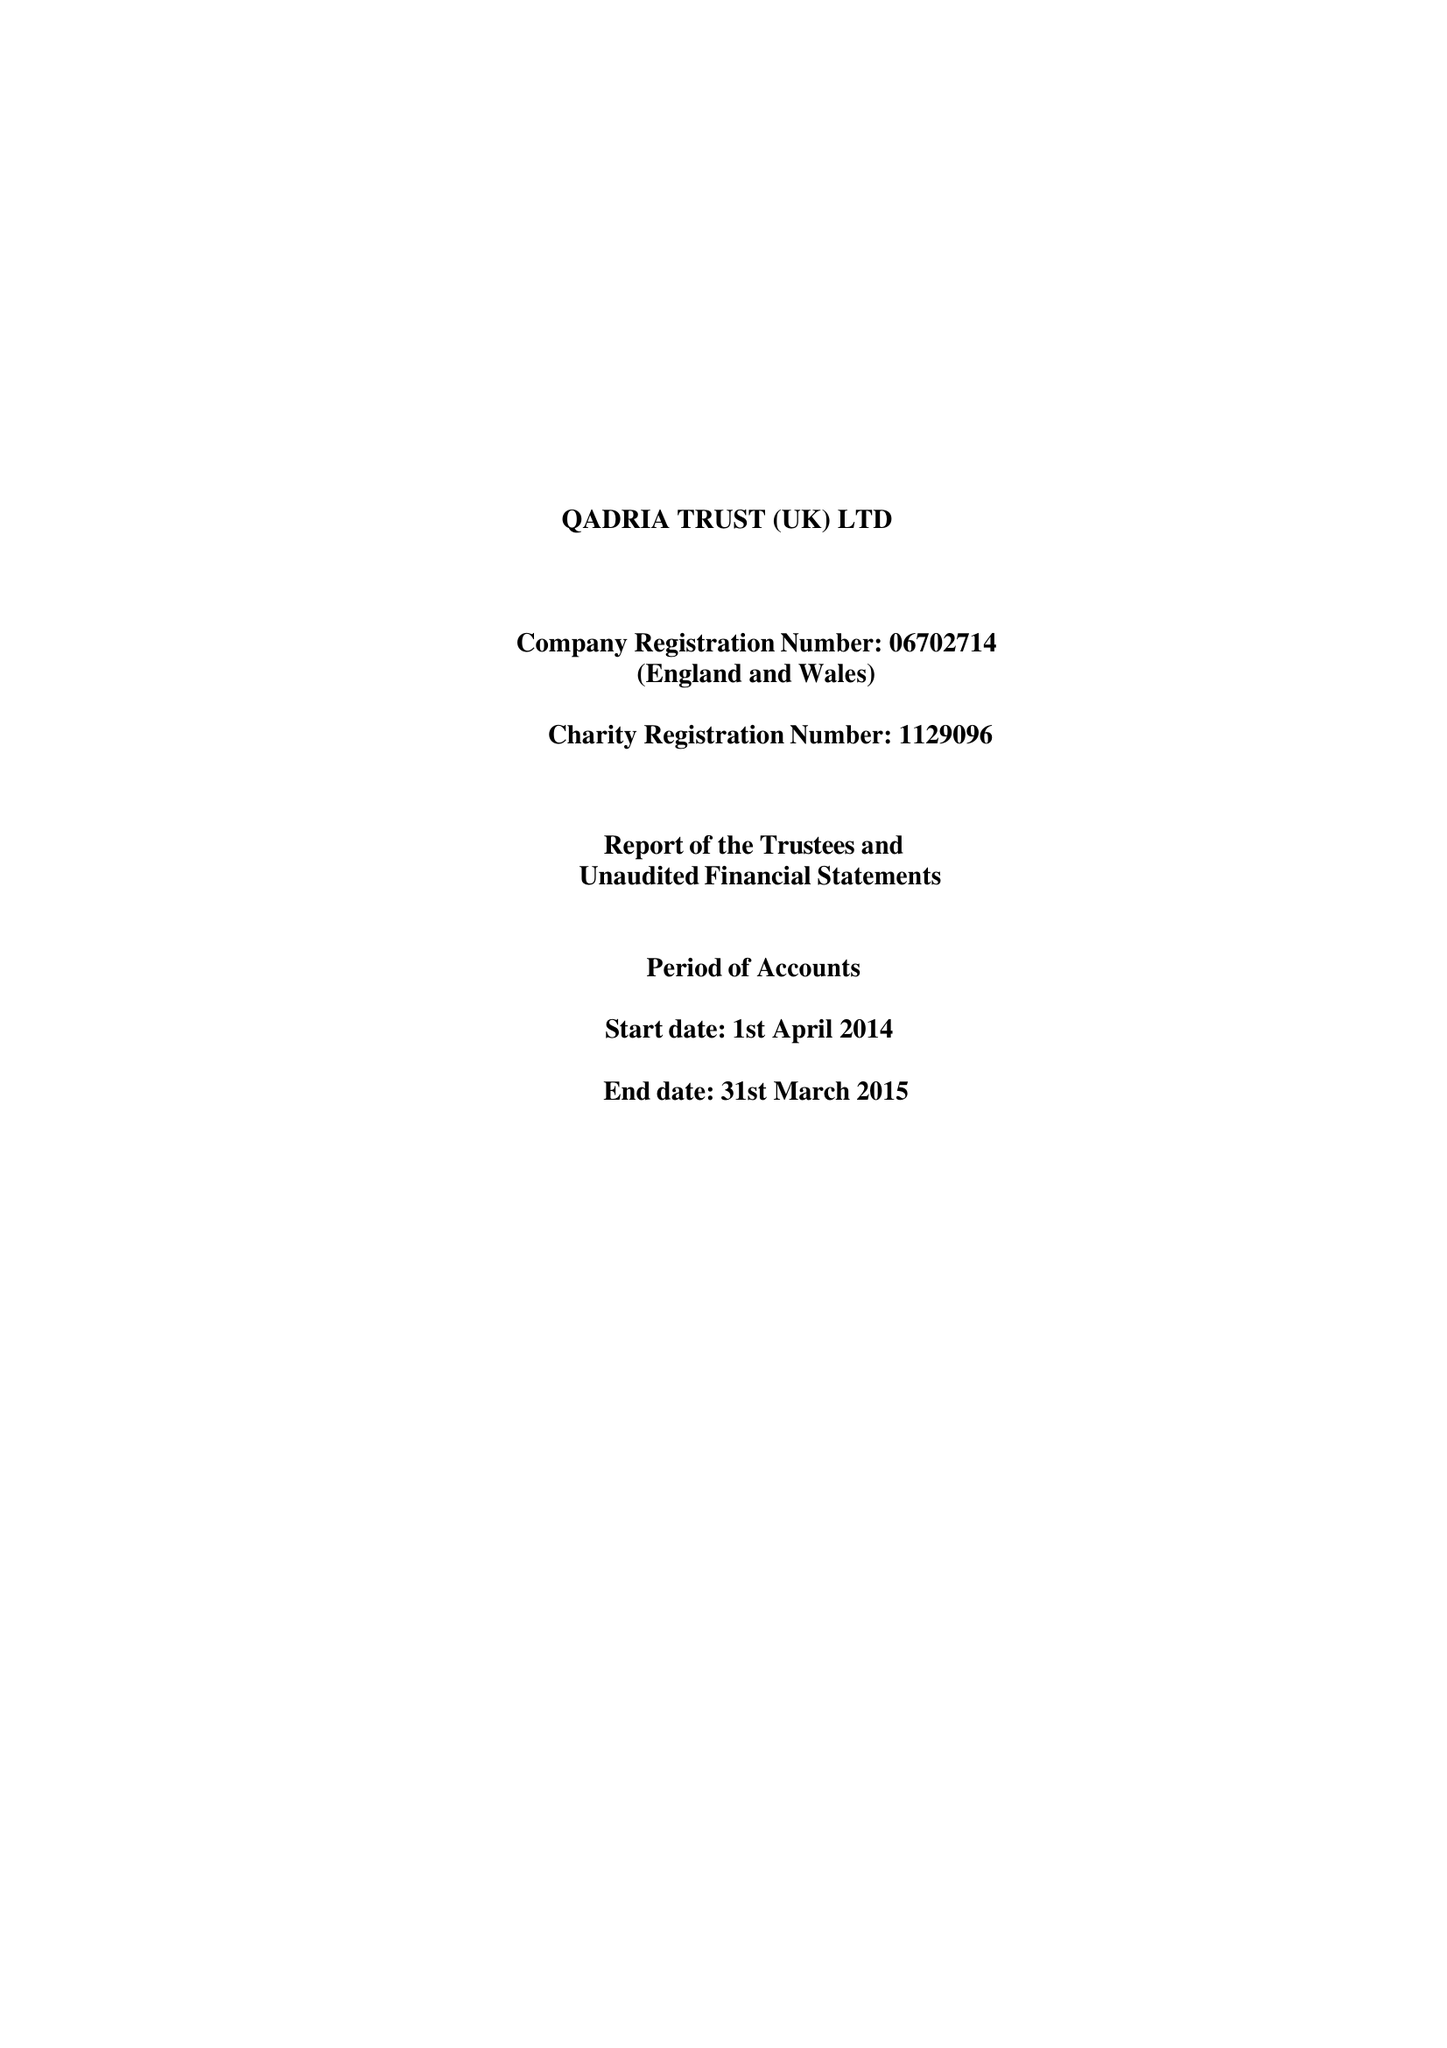What is the value for the charity_name?
Answer the question using a single word or phrase. Qadria Trust (Uk) 